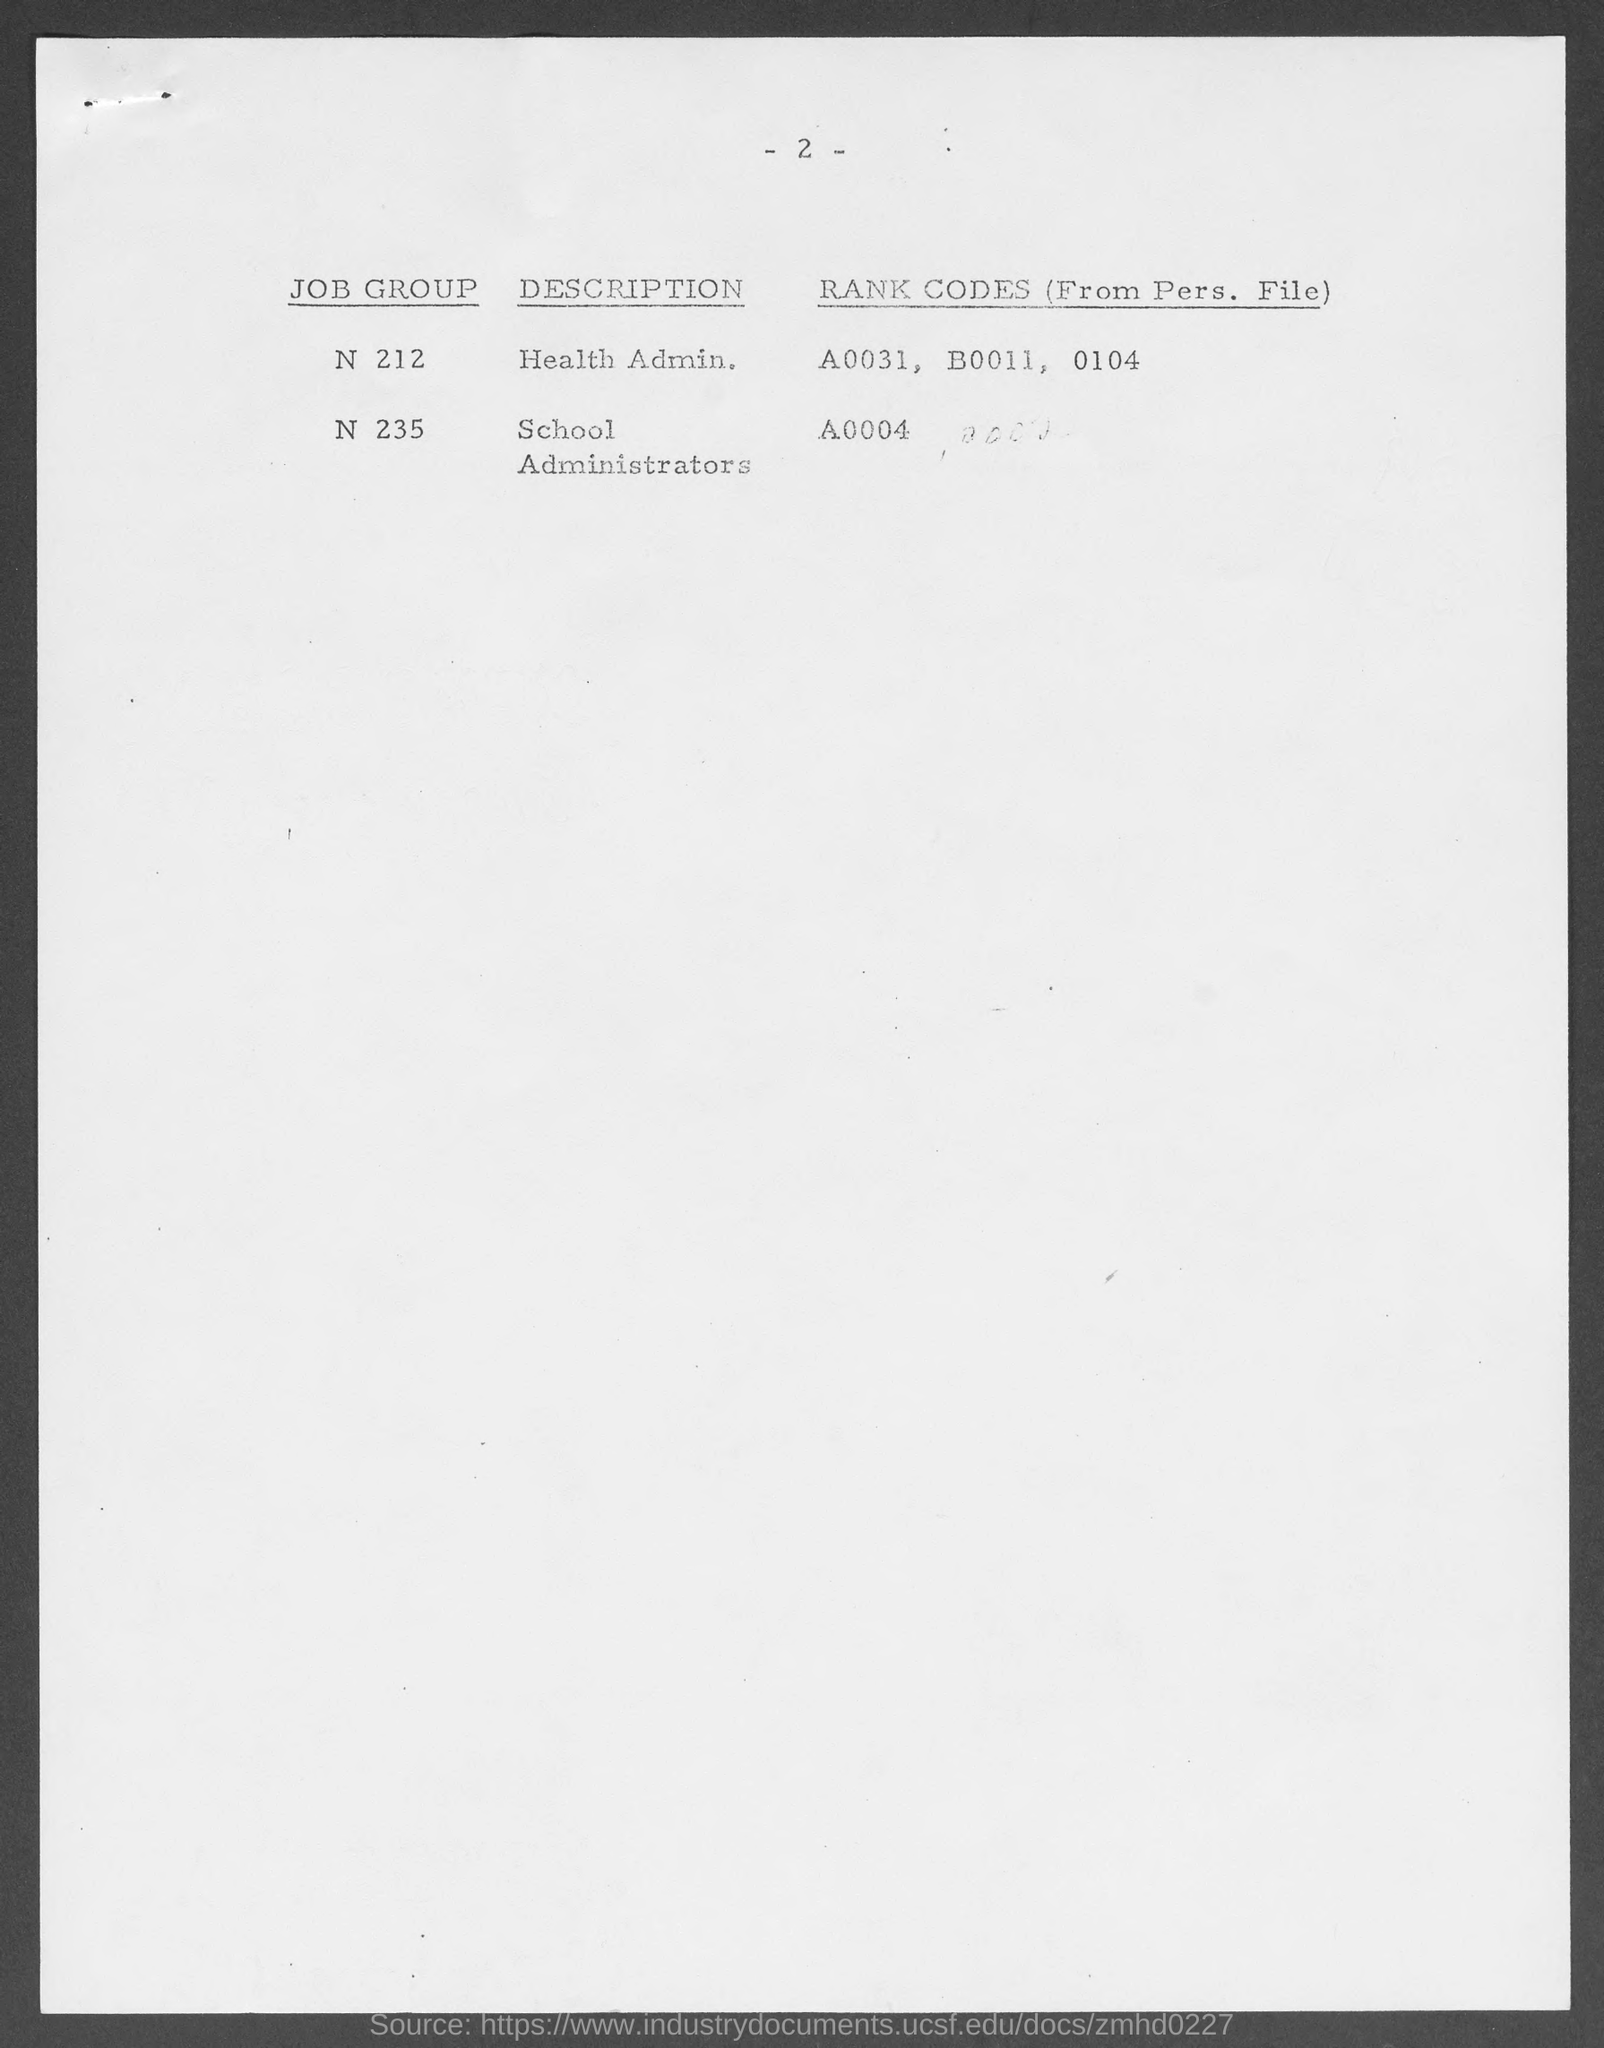What is the description for job group 'N 212'?
Your response must be concise. HEALTH ADMIN. What is the description for job group 'N 235'?
Offer a very short reply. School Administrators. What are the rank codes for job group N212?
Give a very brief answer. A0031, B0011, 0104. What is the rank code for job group N235?
Ensure brevity in your answer.  A0004. 